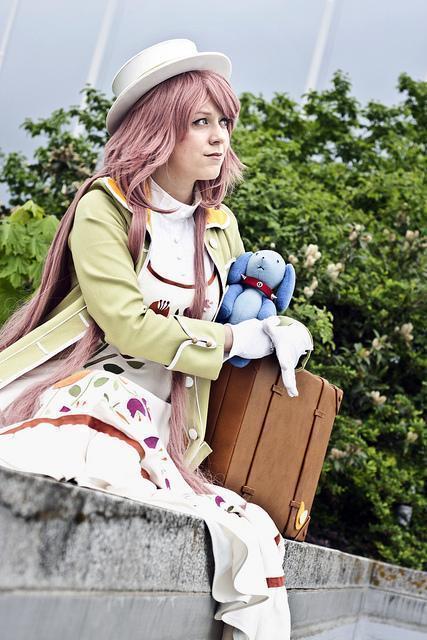What is next to the girl?
Select the accurate answer and provide explanation: 'Answer: answer
Rationale: rationale.'
Options: Pumpkin, luggage, apple, cow. Answer: luggage.
Rationale: This looks like cosplay and even makes sense if she's an anime character. 